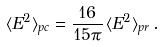Convert formula to latex. <formula><loc_0><loc_0><loc_500><loc_500>\langle E ^ { 2 } \rangle _ { p c } = \frac { 1 6 } { 1 5 \pi } \, \langle E ^ { 2 } \rangle _ { p r } \, .</formula> 